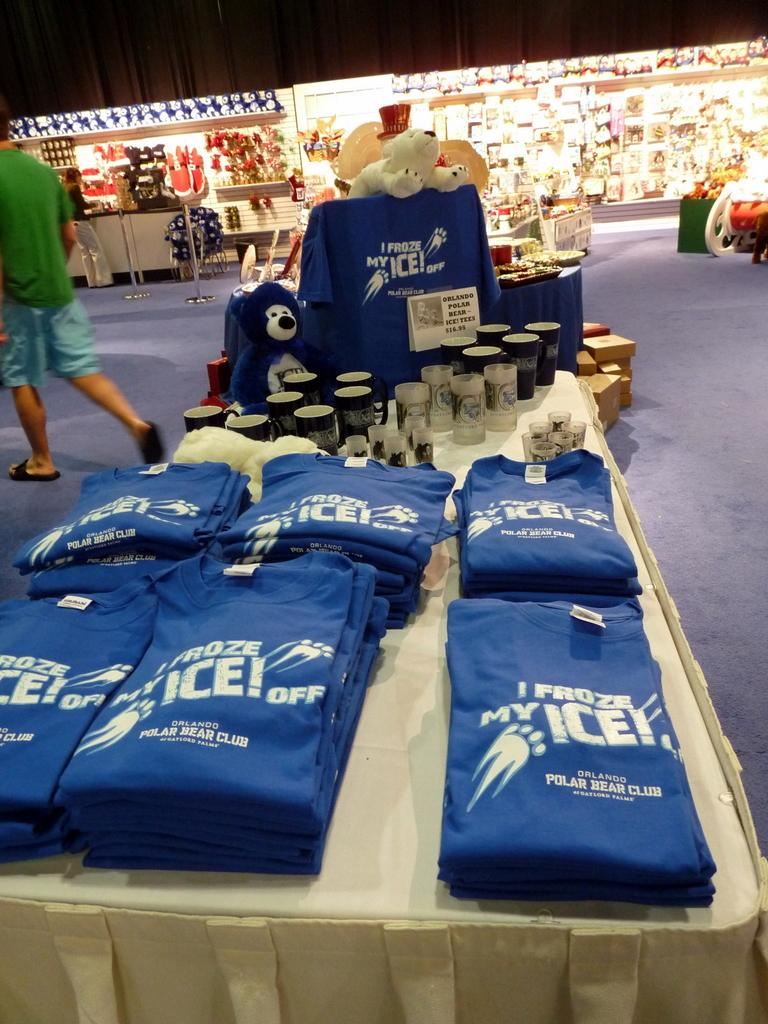Provide a one-sentence caption for the provided image. table with various items for orlando polar bear club. 